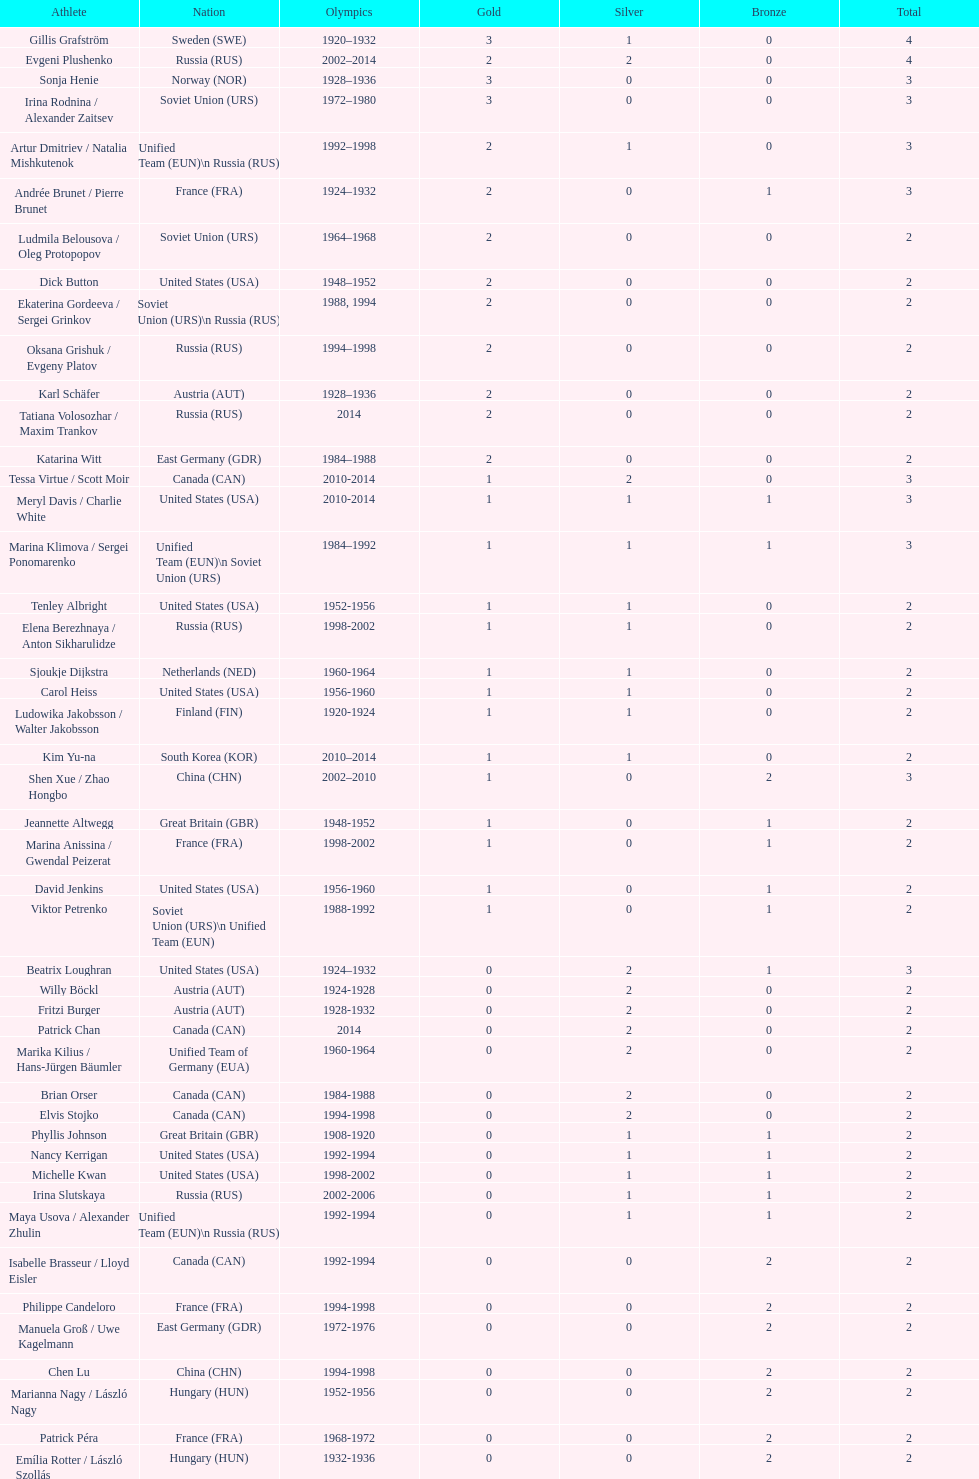What was the greatest number of gold medals won by a single athlete? 3. 